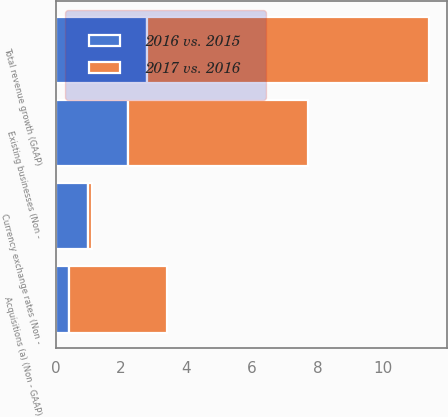<chart> <loc_0><loc_0><loc_500><loc_500><stacked_bar_chart><ecel><fcel>Total revenue growth (GAAP)<fcel>Existing businesses (Non -<fcel>Acquisitions (a) (Non - GAAP)<fcel>Currency exchange rates (Non -<nl><fcel>2017 vs. 2016<fcel>8.6<fcel>5.5<fcel>3<fcel>0.1<nl><fcel>2016 vs. 2015<fcel>2.8<fcel>2.2<fcel>0.4<fcel>1<nl></chart> 